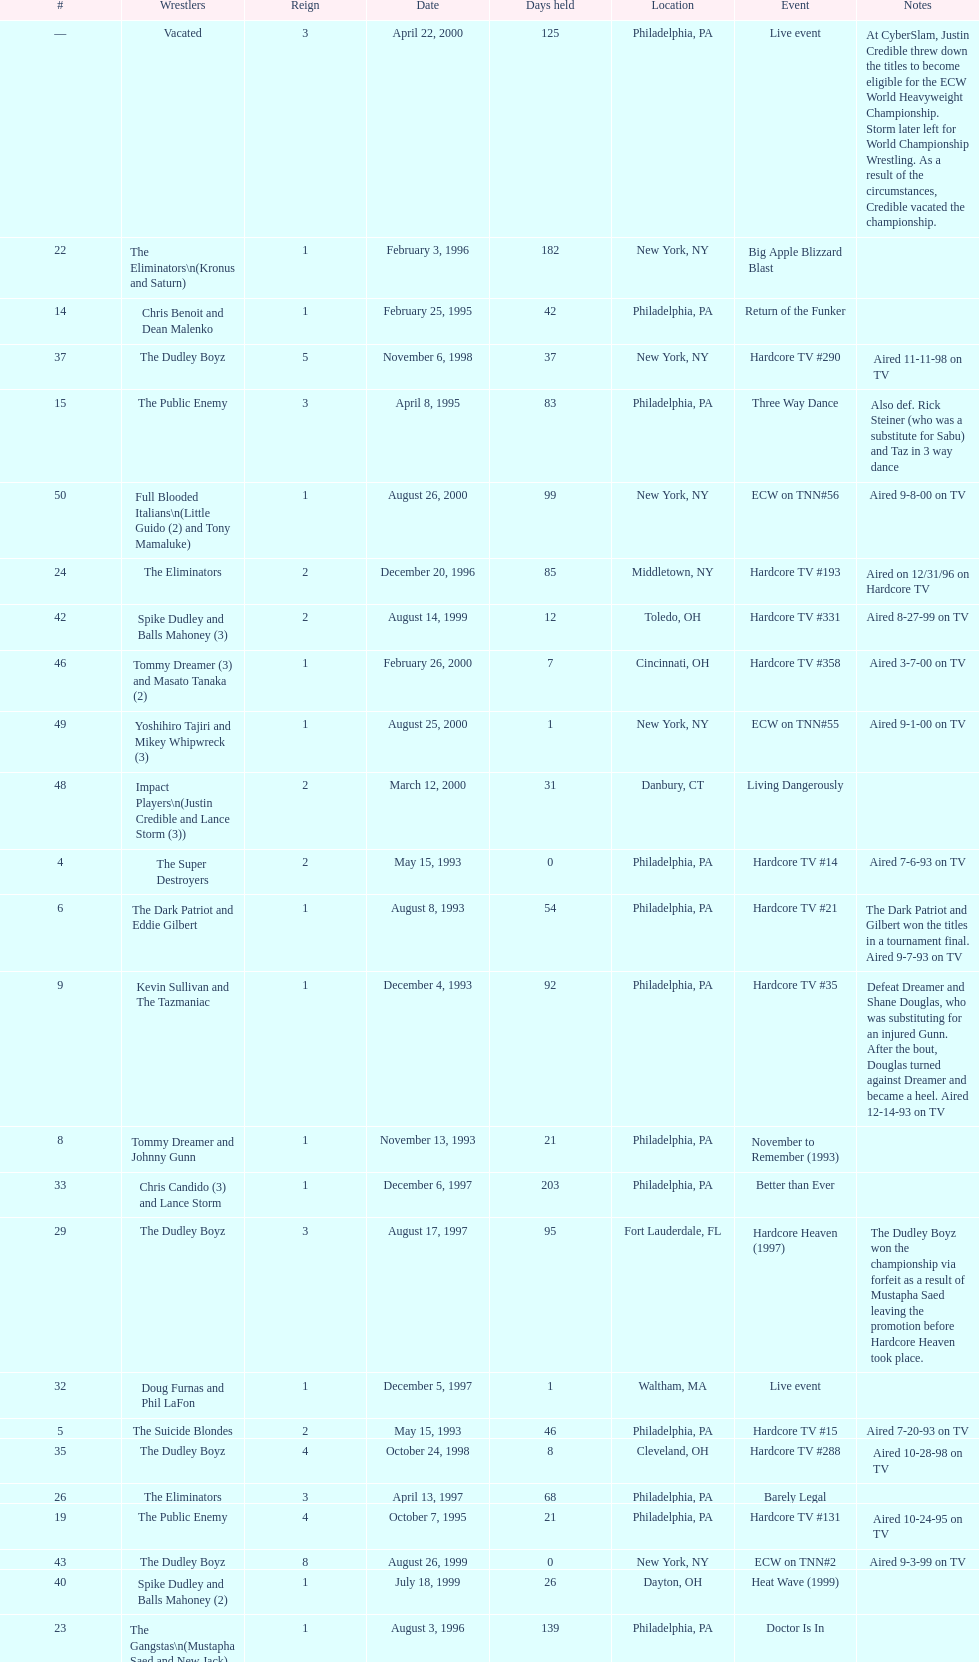Who held the title before the public enemy regained it on april 8th, 1995? Chris Benoit and Dean Malenko. 